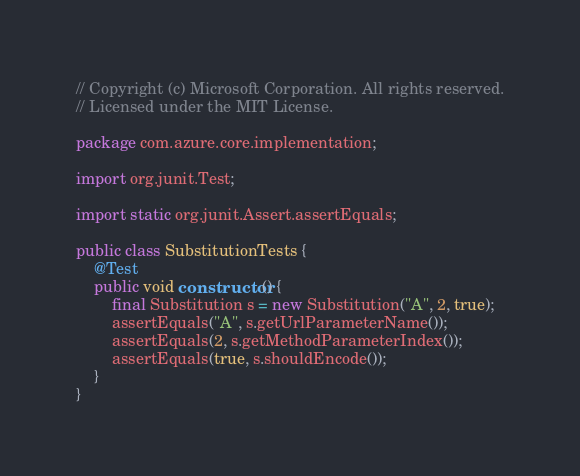Convert code to text. <code><loc_0><loc_0><loc_500><loc_500><_Java_>// Copyright (c) Microsoft Corporation. All rights reserved.
// Licensed under the MIT License.

package com.azure.core.implementation;

import org.junit.Test;

import static org.junit.Assert.assertEquals;

public class SubstitutionTests {
    @Test
    public void constructor() {
        final Substitution s = new Substitution("A", 2, true);
        assertEquals("A", s.getUrlParameterName());
        assertEquals(2, s.getMethodParameterIndex());
        assertEquals(true, s.shouldEncode());
    }
}
</code> 